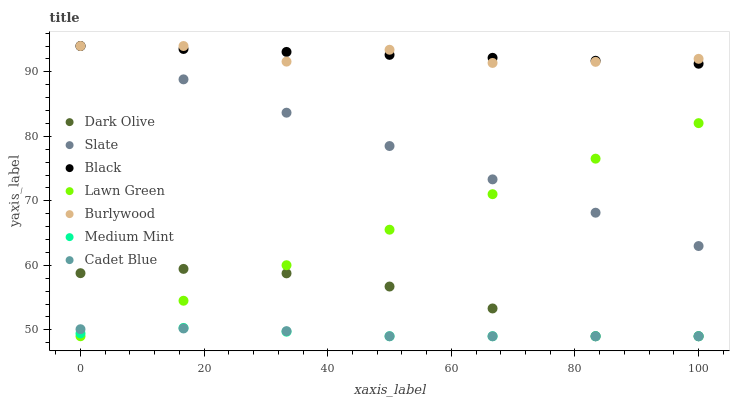Does Medium Mint have the minimum area under the curve?
Answer yes or no. Yes. Does Black have the maximum area under the curve?
Answer yes or no. Yes. Does Lawn Green have the minimum area under the curve?
Answer yes or no. No. Does Lawn Green have the maximum area under the curve?
Answer yes or no. No. Is Lawn Green the smoothest?
Answer yes or no. Yes. Is Burlywood the roughest?
Answer yes or no. Yes. Is Cadet Blue the smoothest?
Answer yes or no. No. Is Cadet Blue the roughest?
Answer yes or no. No. Does Medium Mint have the lowest value?
Answer yes or no. Yes. Does Burlywood have the lowest value?
Answer yes or no. No. Does Black have the highest value?
Answer yes or no. Yes. Does Lawn Green have the highest value?
Answer yes or no. No. Is Cadet Blue less than Burlywood?
Answer yes or no. Yes. Is Burlywood greater than Lawn Green?
Answer yes or no. Yes. Does Slate intersect Burlywood?
Answer yes or no. Yes. Is Slate less than Burlywood?
Answer yes or no. No. Is Slate greater than Burlywood?
Answer yes or no. No. Does Cadet Blue intersect Burlywood?
Answer yes or no. No. 